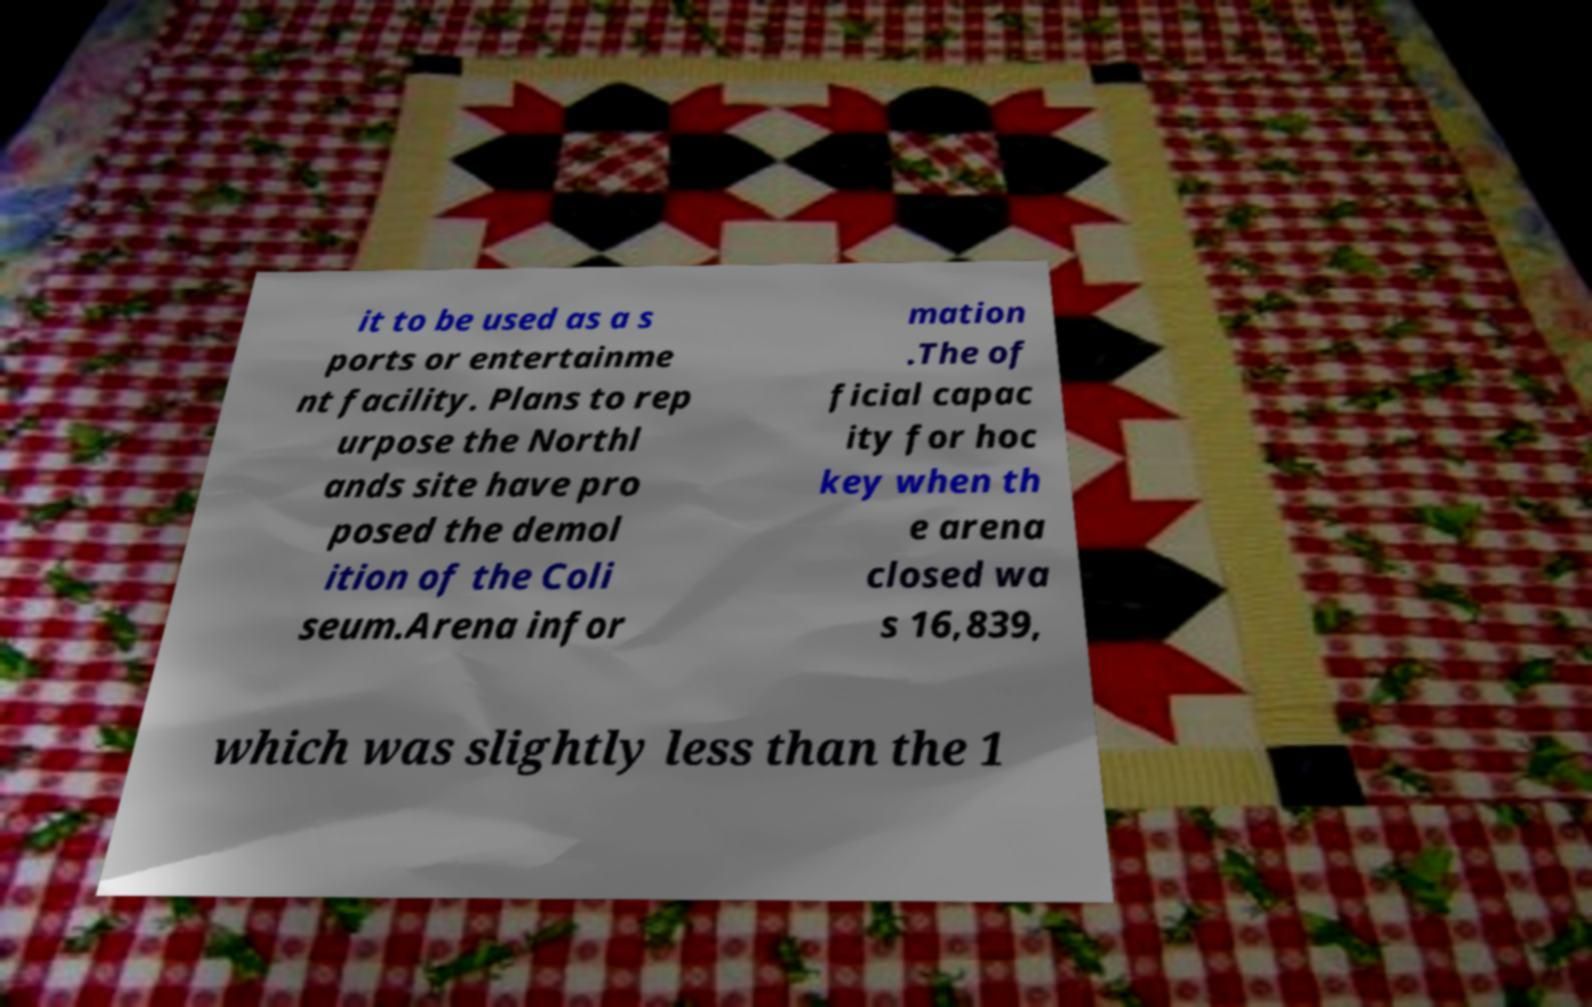I need the written content from this picture converted into text. Can you do that? it to be used as a s ports or entertainme nt facility. Plans to rep urpose the Northl ands site have pro posed the demol ition of the Coli seum.Arena infor mation .The of ficial capac ity for hoc key when th e arena closed wa s 16,839, which was slightly less than the 1 